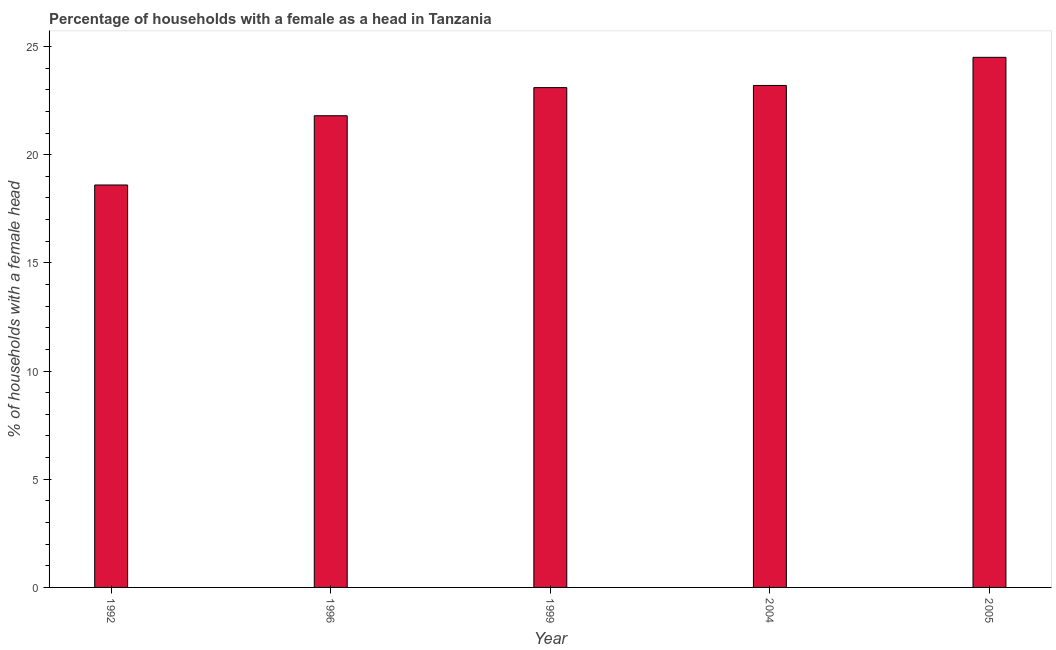Does the graph contain any zero values?
Your answer should be compact. No. Does the graph contain grids?
Keep it short and to the point. No. What is the title of the graph?
Offer a terse response. Percentage of households with a female as a head in Tanzania. What is the label or title of the X-axis?
Provide a short and direct response. Year. What is the label or title of the Y-axis?
Keep it short and to the point. % of households with a female head. What is the number of female supervised households in 1999?
Provide a short and direct response. 23.1. Across all years, what is the maximum number of female supervised households?
Keep it short and to the point. 24.5. What is the sum of the number of female supervised households?
Provide a succinct answer. 111.2. What is the average number of female supervised households per year?
Offer a very short reply. 22.24. What is the median number of female supervised households?
Provide a succinct answer. 23.1. In how many years, is the number of female supervised households greater than 19 %?
Give a very brief answer. 4. What is the ratio of the number of female supervised households in 1999 to that in 2005?
Your answer should be compact. 0.94. What is the difference between the highest and the second highest number of female supervised households?
Give a very brief answer. 1.3. Is the sum of the number of female supervised households in 1992 and 2004 greater than the maximum number of female supervised households across all years?
Ensure brevity in your answer.  Yes. In how many years, is the number of female supervised households greater than the average number of female supervised households taken over all years?
Keep it short and to the point. 3. How many years are there in the graph?
Provide a short and direct response. 5. What is the % of households with a female head of 1992?
Your answer should be compact. 18.6. What is the % of households with a female head in 1996?
Your answer should be compact. 21.8. What is the % of households with a female head of 1999?
Provide a short and direct response. 23.1. What is the % of households with a female head in 2004?
Your answer should be very brief. 23.2. What is the % of households with a female head in 2005?
Make the answer very short. 24.5. What is the difference between the % of households with a female head in 1992 and 1996?
Provide a succinct answer. -3.2. What is the difference between the % of households with a female head in 1992 and 2004?
Ensure brevity in your answer.  -4.6. What is the difference between the % of households with a female head in 1996 and 2004?
Your answer should be compact. -1.4. What is the difference between the % of households with a female head in 1996 and 2005?
Your answer should be compact. -2.7. What is the difference between the % of households with a female head in 1999 and 2004?
Your answer should be very brief. -0.1. What is the difference between the % of households with a female head in 1999 and 2005?
Offer a terse response. -1.4. What is the ratio of the % of households with a female head in 1992 to that in 1996?
Provide a succinct answer. 0.85. What is the ratio of the % of households with a female head in 1992 to that in 1999?
Provide a succinct answer. 0.81. What is the ratio of the % of households with a female head in 1992 to that in 2004?
Your answer should be compact. 0.8. What is the ratio of the % of households with a female head in 1992 to that in 2005?
Offer a very short reply. 0.76. What is the ratio of the % of households with a female head in 1996 to that in 1999?
Your response must be concise. 0.94. What is the ratio of the % of households with a female head in 1996 to that in 2005?
Make the answer very short. 0.89. What is the ratio of the % of households with a female head in 1999 to that in 2005?
Provide a succinct answer. 0.94. What is the ratio of the % of households with a female head in 2004 to that in 2005?
Keep it short and to the point. 0.95. 